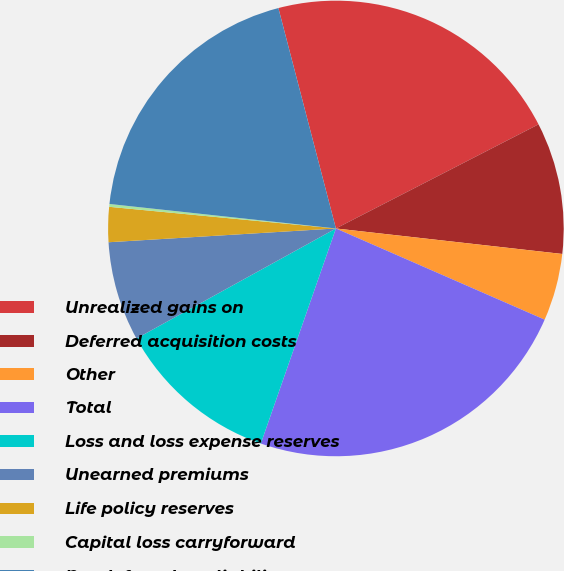Convert chart. <chart><loc_0><loc_0><loc_500><loc_500><pie_chart><fcel>Unrealized gains on<fcel>Deferred acquisition costs<fcel>Other<fcel>Total<fcel>Loss and loss expense reserves<fcel>Unearned premiums<fcel>Life policy reserves<fcel>Capital loss carryforward<fcel>Net deferred tax liability<nl><fcel>21.51%<fcel>9.34%<fcel>4.77%<fcel>23.79%<fcel>11.63%<fcel>7.06%<fcel>2.48%<fcel>0.2%<fcel>19.22%<nl></chart> 